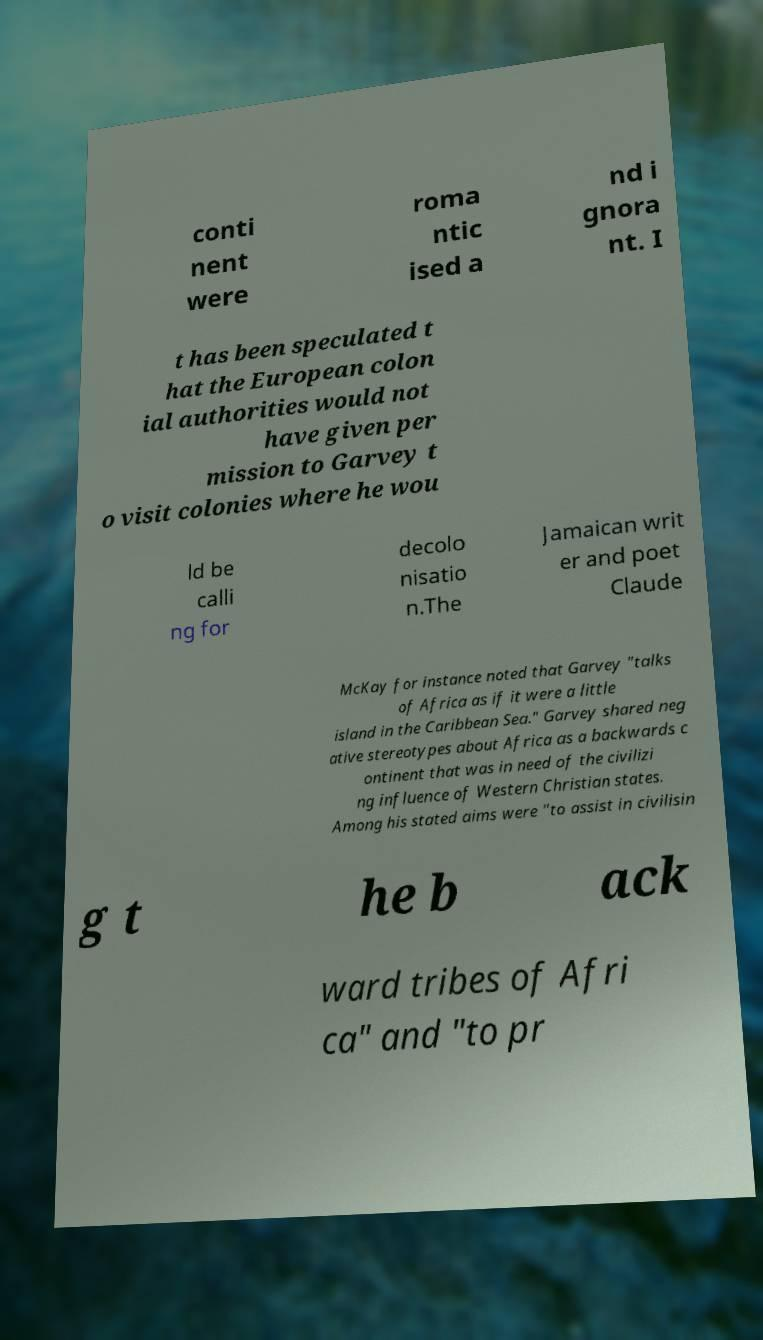There's text embedded in this image that I need extracted. Can you transcribe it verbatim? conti nent were roma ntic ised a nd i gnora nt. I t has been speculated t hat the European colon ial authorities would not have given per mission to Garvey t o visit colonies where he wou ld be calli ng for decolo nisatio n.The Jamaican writ er and poet Claude McKay for instance noted that Garvey "talks of Africa as if it were a little island in the Caribbean Sea." Garvey shared neg ative stereotypes about Africa as a backwards c ontinent that was in need of the civilizi ng influence of Western Christian states. Among his stated aims were "to assist in civilisin g t he b ack ward tribes of Afri ca" and "to pr 